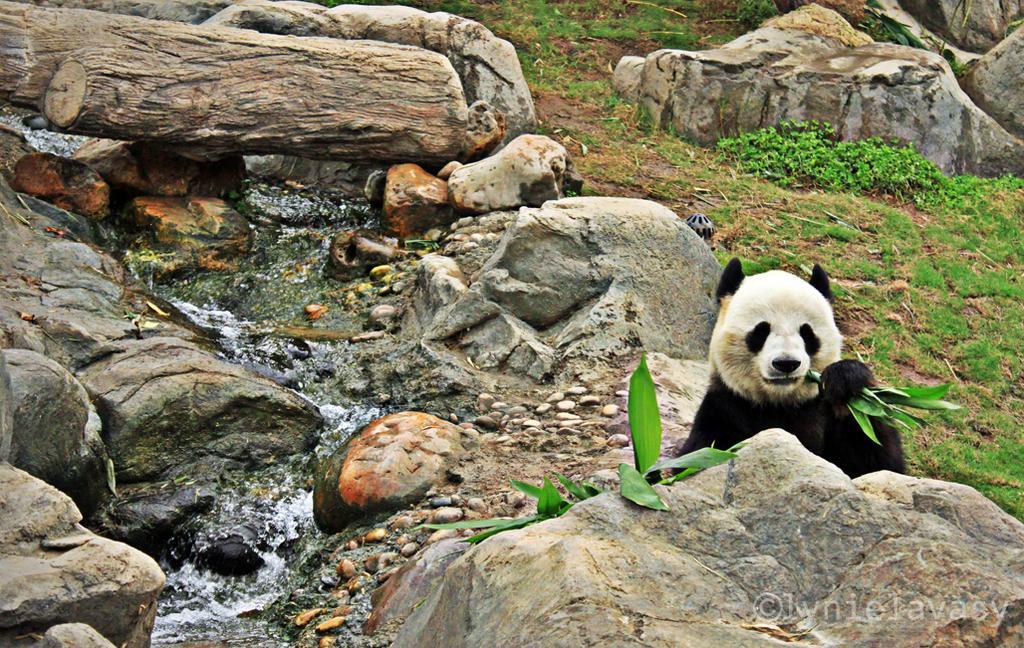Describe this image in one or two sentences. In this image, we can see a panda is holding a leaves. Here we can see rocks, stones, water flow, plants, grass,tree trunk. Right side bottom of the image, we can see a watermark. 